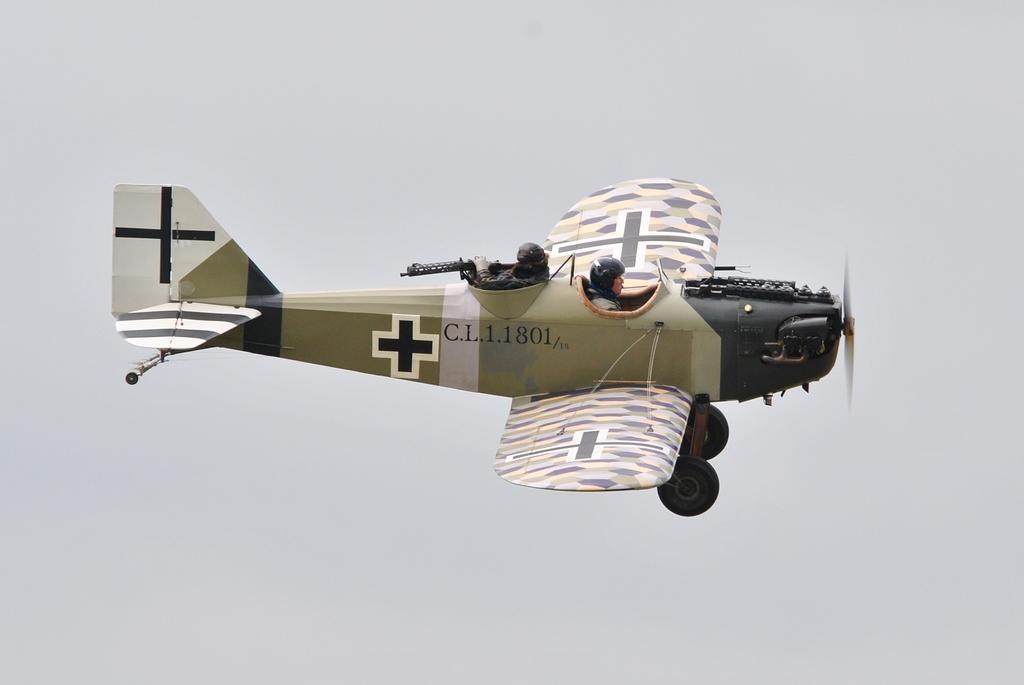In one or two sentences, can you explain what this image depicts? In this image we can see the aircraft and also two persons. In the background there is sky. 